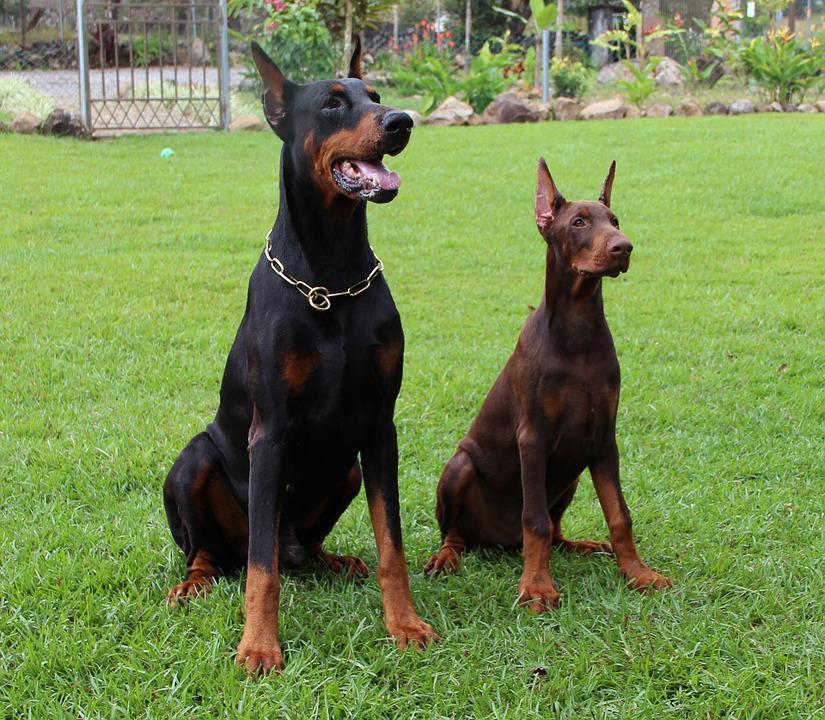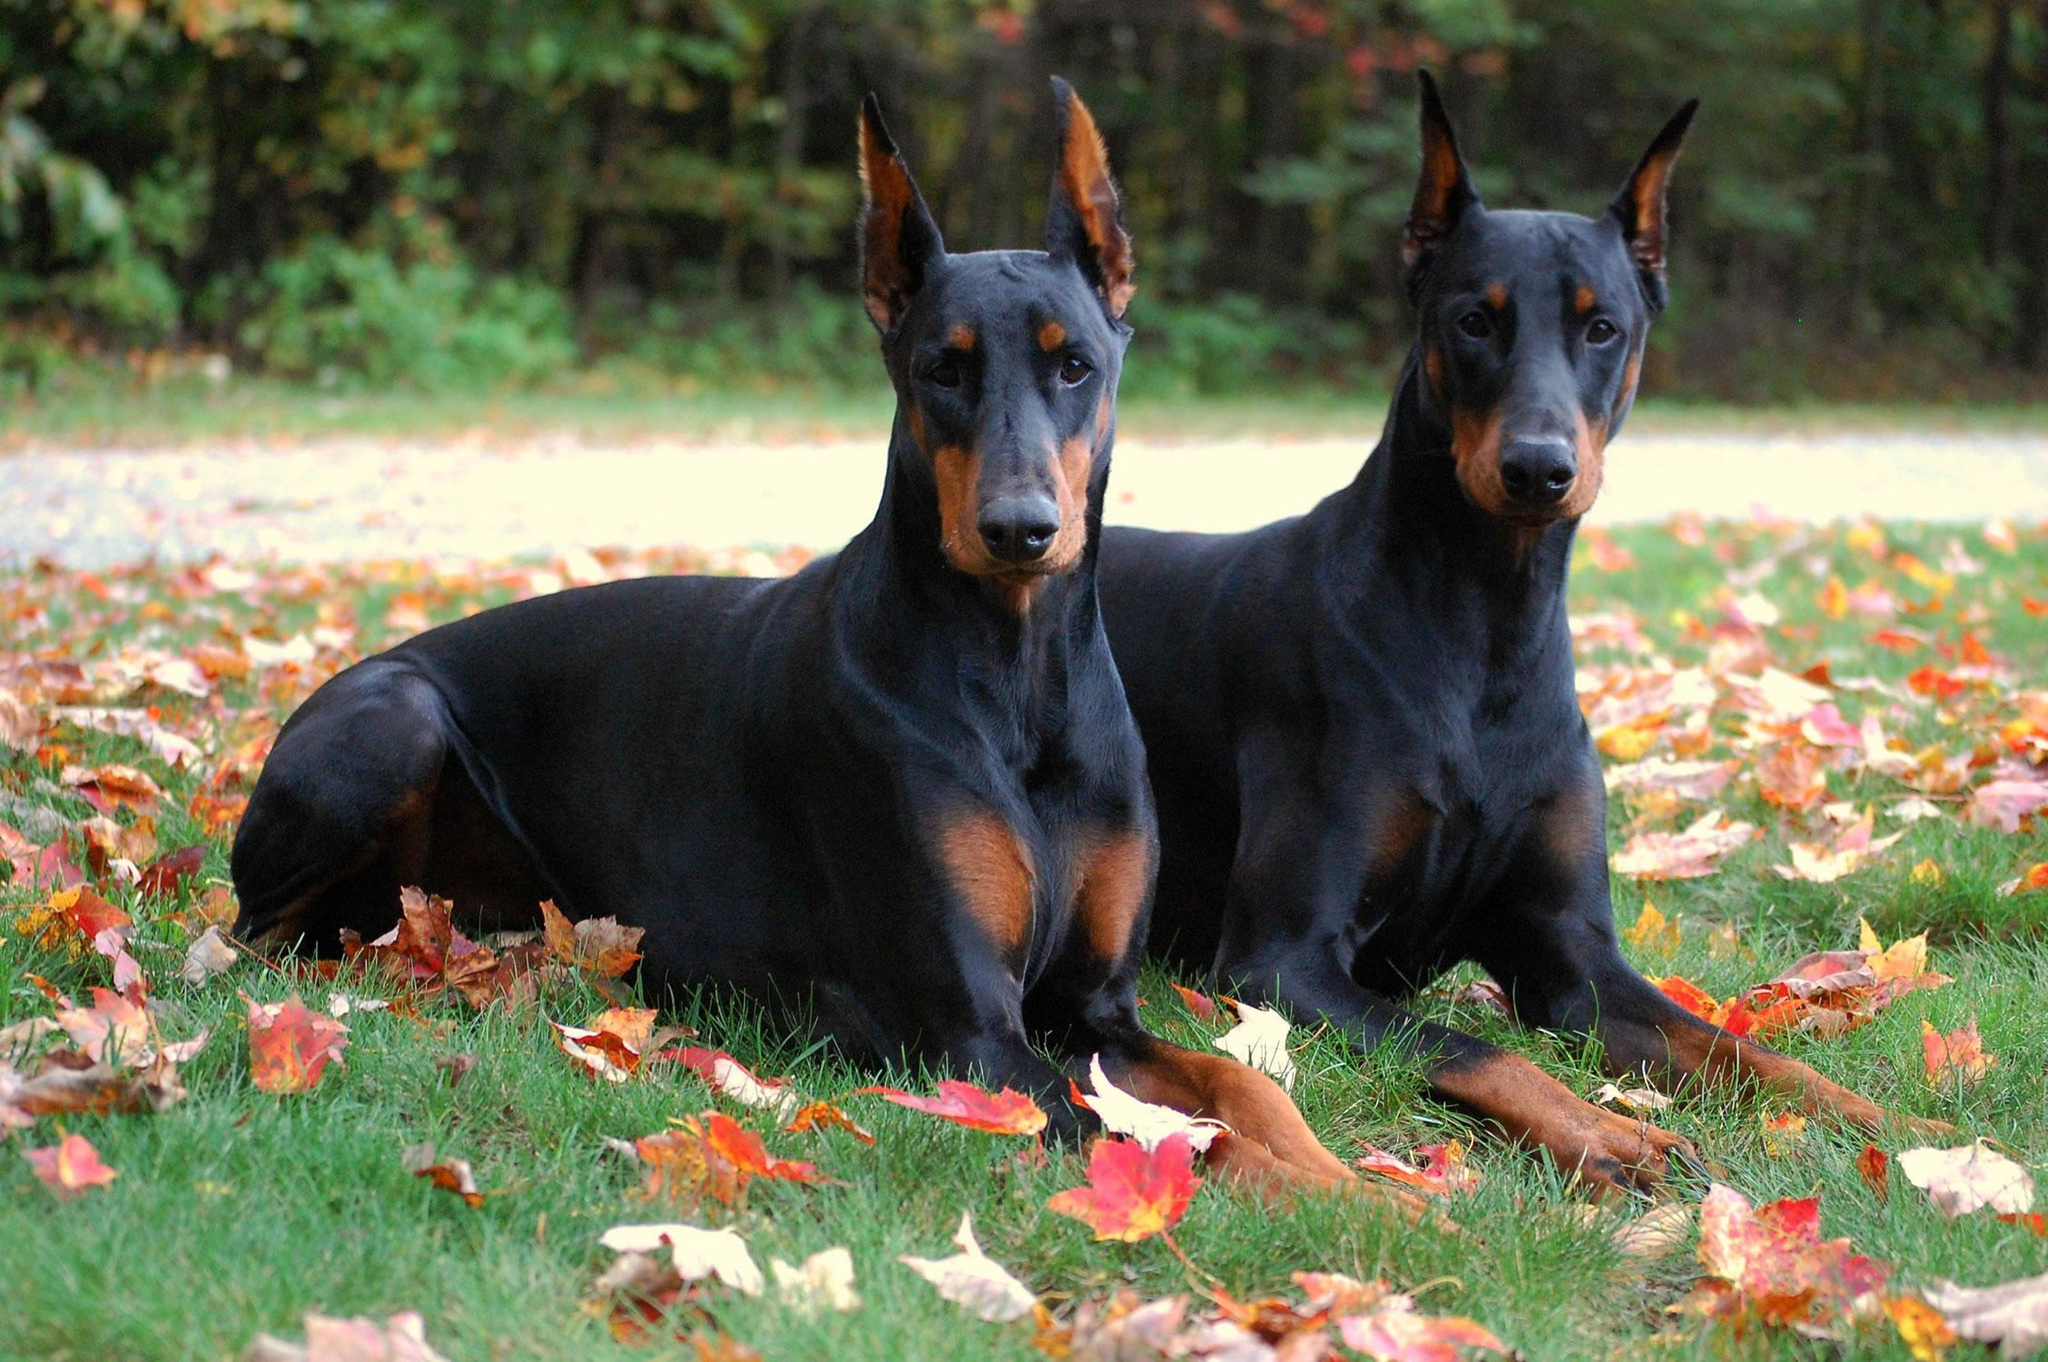The first image is the image on the left, the second image is the image on the right. Examine the images to the left and right. Is the description "At least one dog has its mouth open in one picture and none do in the other." accurate? Answer yes or no. Yes. The first image is the image on the left, the second image is the image on the right. Analyze the images presented: Is the assertion "One image contains two dobermans sitting upright side-by side, and the other image features two dobermans reclining side-by-side." valid? Answer yes or no. Yes. 